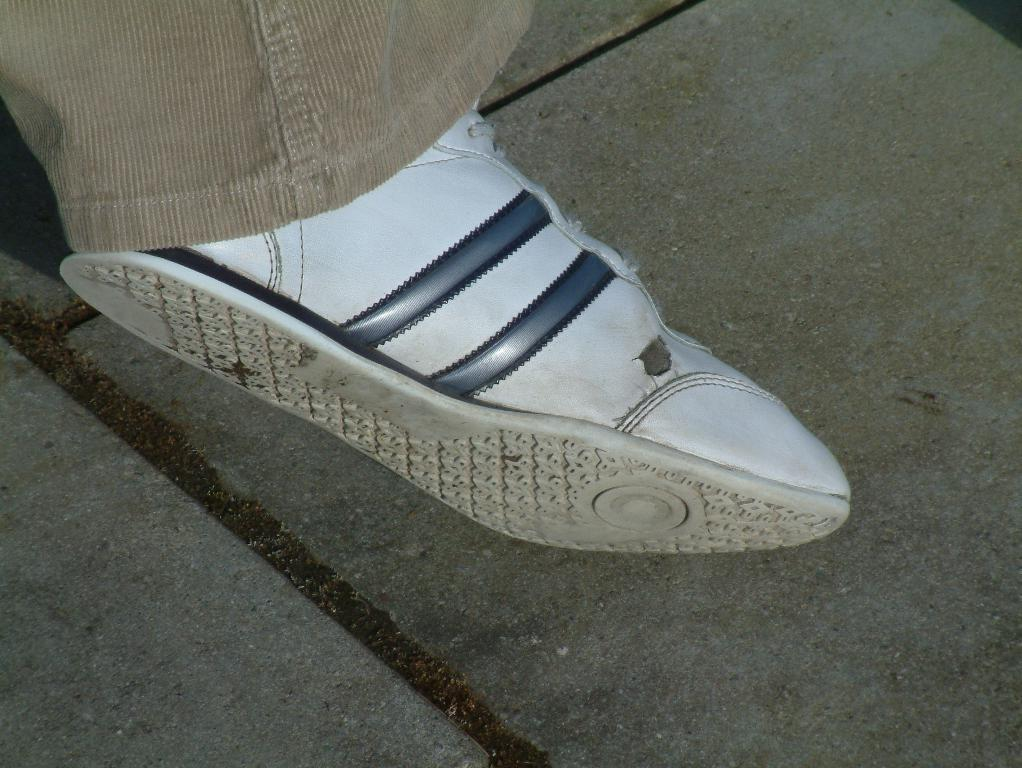What type of footwear is present in the image? There is a white shoe in the image. What else can be seen in the image besides the shoe? There is a cloth and tiles visible in the image. Can you describe the surface behind the shoe? The tiles are visible behind the shoe. What type of rice is being served in the image? There is no rice present in the image; it features a white shoe, a cloth, and tiles. 